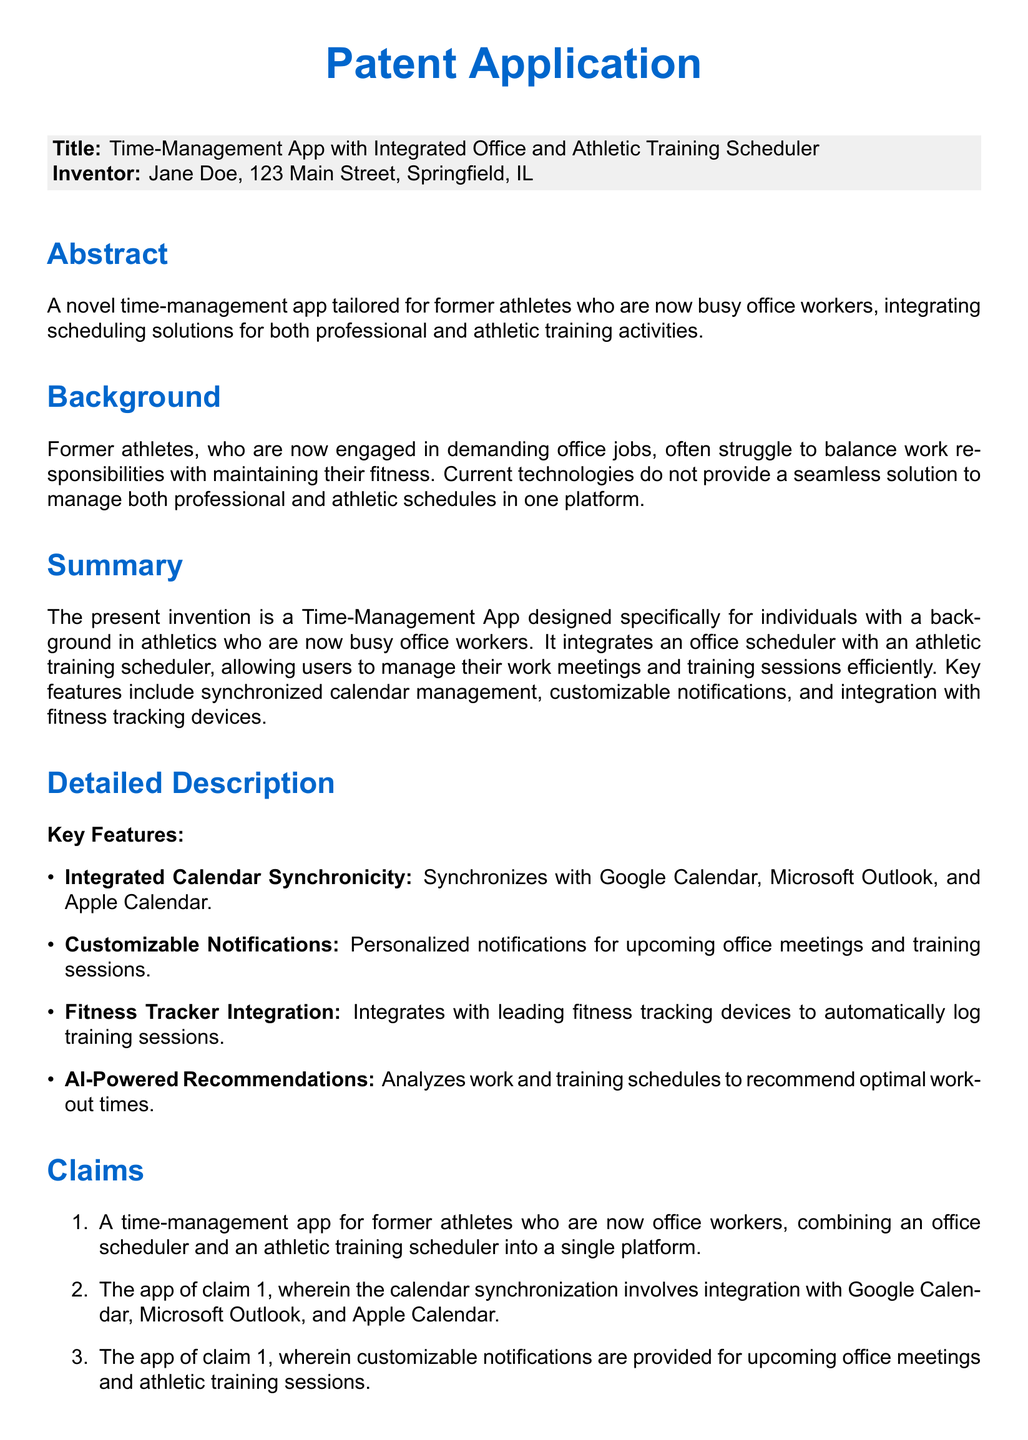What is the title of the patent application? The title of the patent application is stated clearly in the document's title section.
Answer: Time-Management App with Integrated Office and Athletic Training Scheduler Who is the inventor? The inventor's name is listed in the document along with an address in the inventor's section.
Answer: Jane Doe What is the main purpose of the app? The abstract provides a summary of the purpose of the app, focusing on its target audience and functionality.
Answer: To integrate scheduling solutions for both professional and athletic training activities Which calendars does the app synchronize with? The detailed description lists specific services that the app is designed to synchronize with.
Answer: Google Calendar, Microsoft Outlook, and Apple Calendar How many claims are presented in the document? The number of claims is referenced in the claims section of the document.
Answer: Five What feature analyzes schedules to recommend workout times? The detailed description specifies a feature within the app that provides this analysis.
Answer: AI-Powered Recommendations What type of notifications does the app provide? The key features section describes the type of notifications available to users.
Answer: Customizable Notifications What is the focus of the background section? The background section explains the challenges faced by the target users of the app.
Answer: Balancing work responsibilities with maintaining fitness 